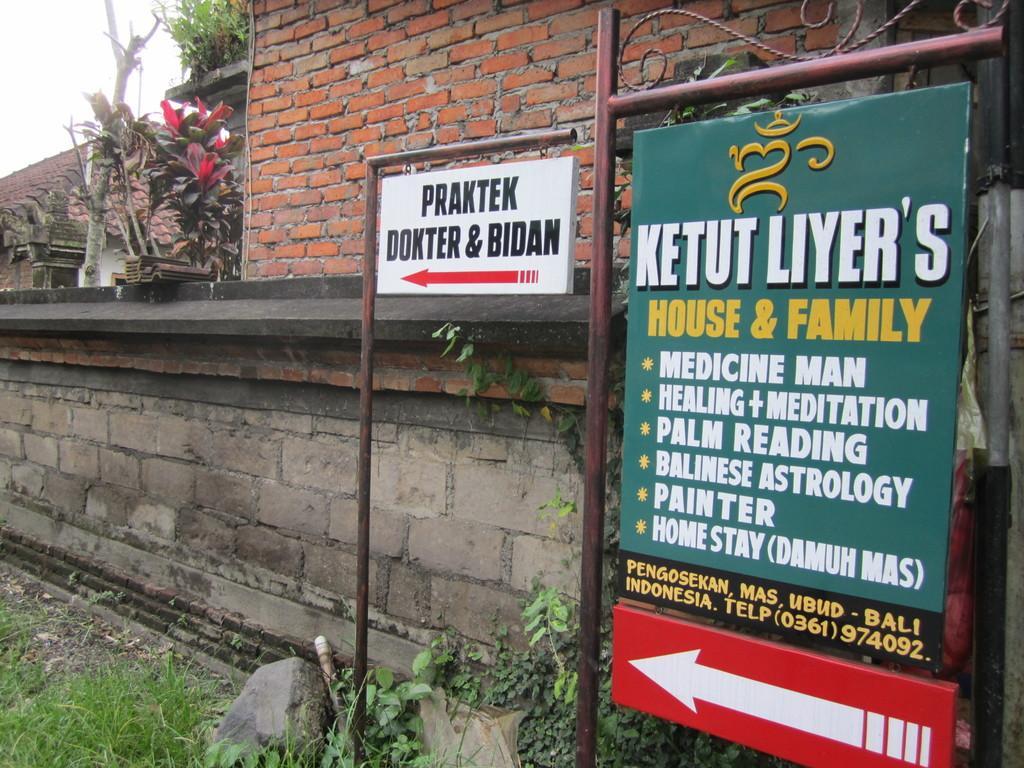Can you describe this image briefly? In this image I can see three boards. There is some text on the boards. In the background there is a wall. There is some grass on the ground. I can see a building. At the top I can see the sky. 